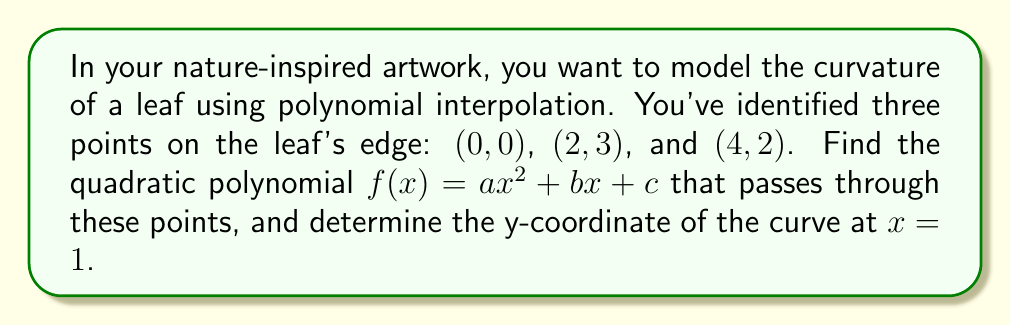Provide a solution to this math problem. 1) We need to find a quadratic polynomial $f(x) = ax^2 + bx + c$ that satisfies:

   $f(0) = 0$
   $f(2) = 3$
   $f(4) = 2$

2) Substituting these points into the general form:

   $0 = a(0)^2 + b(0) + c$
   $3 = a(2)^2 + b(2) + c$
   $2 = a(4)^2 + b(4) + c$

3) Simplifying:

   $0 = c$
   $3 = 4a + 2b$
   $2 = 16a + 4b$

4) From the first equation, we know $c = 0$. Subtracting the second equation from the third:

   $-1 = 12a + 2b$

5) Multiplying the second equation by 2 and subtracting from the third:

   $-4 = 8a$

6) Solving for $a$:

   $a = -\frac{1}{2}$

7) Substituting this back into $3 = 4a + 2b$:

   $3 = 4(-\frac{1}{2}) + 2b$
   $3 = -2 + 2b$
   $5 = 2b$
   $b = \frac{5}{2}$

8) Therefore, the quadratic polynomial is:

   $f(x) = -\frac{1}{2}x^2 + \frac{5}{2}x$

9) To find the y-coordinate at $x = 1$, we substitute $x = 1$ into our function:

   $f(1) = -\frac{1}{2}(1)^2 + \frac{5}{2}(1) = -\frac{1}{2} + \frac{5}{2} = 2$
Answer: $2$ 